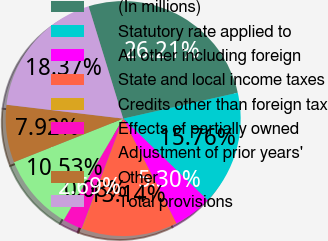Convert chart. <chart><loc_0><loc_0><loc_500><loc_500><pie_chart><fcel>(In millions)<fcel>Statutory rate applied to<fcel>All other including foreign<fcel>State and local income taxes<fcel>Credits other than foreign tax<fcel>Effects of partially owned<fcel>Adjustment of prior years'<fcel>Other<fcel>Total provisions<nl><fcel>26.21%<fcel>15.76%<fcel>5.3%<fcel>13.14%<fcel>0.08%<fcel>2.69%<fcel>10.53%<fcel>7.92%<fcel>18.37%<nl></chart> 